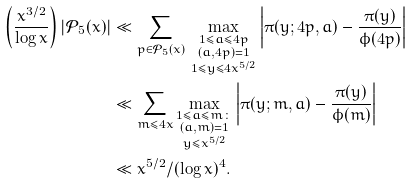Convert formula to latex. <formula><loc_0><loc_0><loc_500><loc_500>\left ( \frac { x ^ { 3 / 2 } } { \log x } \right ) | \mathcal { P } _ { 5 } ( x ) | & \ll \sum _ { p \in \mathcal { P } _ { 5 } ( x ) } \, \max _ { \substack { 1 \leq a \leq 4 p \\ ( a , 4 p ) = 1 \\ 1 \leq y \leq 4 x ^ { 5 / 2 } } } \left | \pi ( y ; 4 p , a ) - \frac { \pi ( y ) } { \phi ( 4 p ) } \right | \\ & \ll \sum _ { m \leq 4 x } \max _ { \substack { 1 \leq a \leq m \colon \\ ( a , m ) = 1 \\ y \leq x ^ { 5 / 2 } } } \left | \pi ( y ; m , a ) - \frac { \pi ( y ) } { \phi ( m ) } \right | \\ & \ll x ^ { 5 / 2 } / ( \log x ) ^ { 4 } .</formula> 